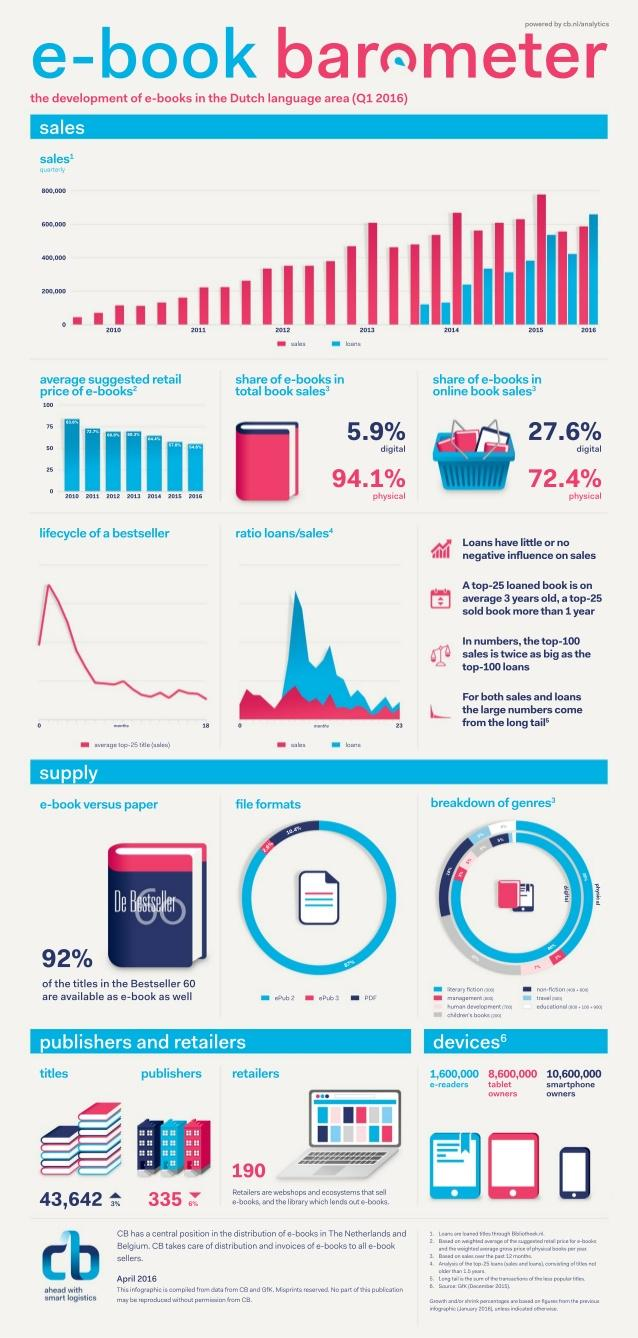Point out several critical features in this image. In the first quarter of 2016, there was a 6% decrease in e-book publishers compared to the previous quarter. In the first quarter of 2016, e-books accounted for 27.6% of online book sales. In Q1 2016, physical books accounted for 94.1% of the total book sales. In Q1 2016, there were 190 retailers that sold e-books. In Q1 2016, there was a 3% increase in the number of e-book titles compared to the previous quarter. 